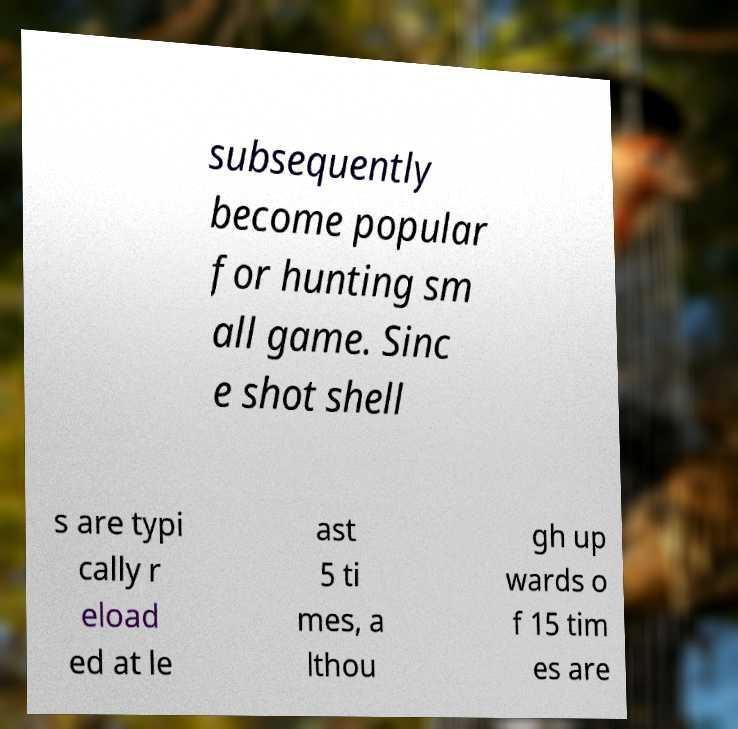Could you assist in decoding the text presented in this image and type it out clearly? subsequently become popular for hunting sm all game. Sinc e shot shell s are typi cally r eload ed at le ast 5 ti mes, a lthou gh up wards o f 15 tim es are 